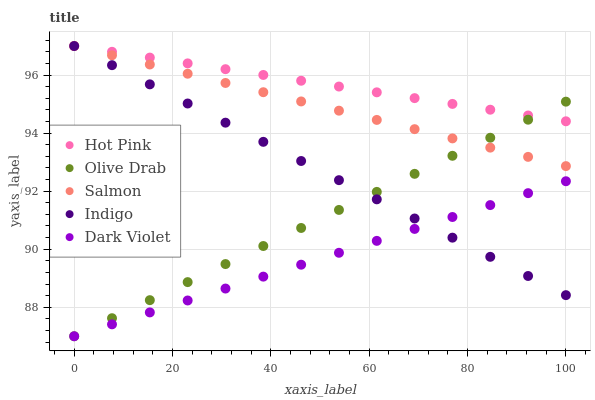Does Dark Violet have the minimum area under the curve?
Answer yes or no. Yes. Does Hot Pink have the maximum area under the curve?
Answer yes or no. Yes. Does Salmon have the minimum area under the curve?
Answer yes or no. No. Does Salmon have the maximum area under the curve?
Answer yes or no. No. Is Salmon the smoothest?
Answer yes or no. Yes. Is Indigo the roughest?
Answer yes or no. Yes. Is Hot Pink the smoothest?
Answer yes or no. No. Is Hot Pink the roughest?
Answer yes or no. No. Does Dark Violet have the lowest value?
Answer yes or no. Yes. Does Salmon have the lowest value?
Answer yes or no. No. Does Salmon have the highest value?
Answer yes or no. Yes. Does Dark Violet have the highest value?
Answer yes or no. No. Is Dark Violet less than Hot Pink?
Answer yes or no. Yes. Is Hot Pink greater than Dark Violet?
Answer yes or no. Yes. Does Indigo intersect Dark Violet?
Answer yes or no. Yes. Is Indigo less than Dark Violet?
Answer yes or no. No. Is Indigo greater than Dark Violet?
Answer yes or no. No. Does Dark Violet intersect Hot Pink?
Answer yes or no. No. 